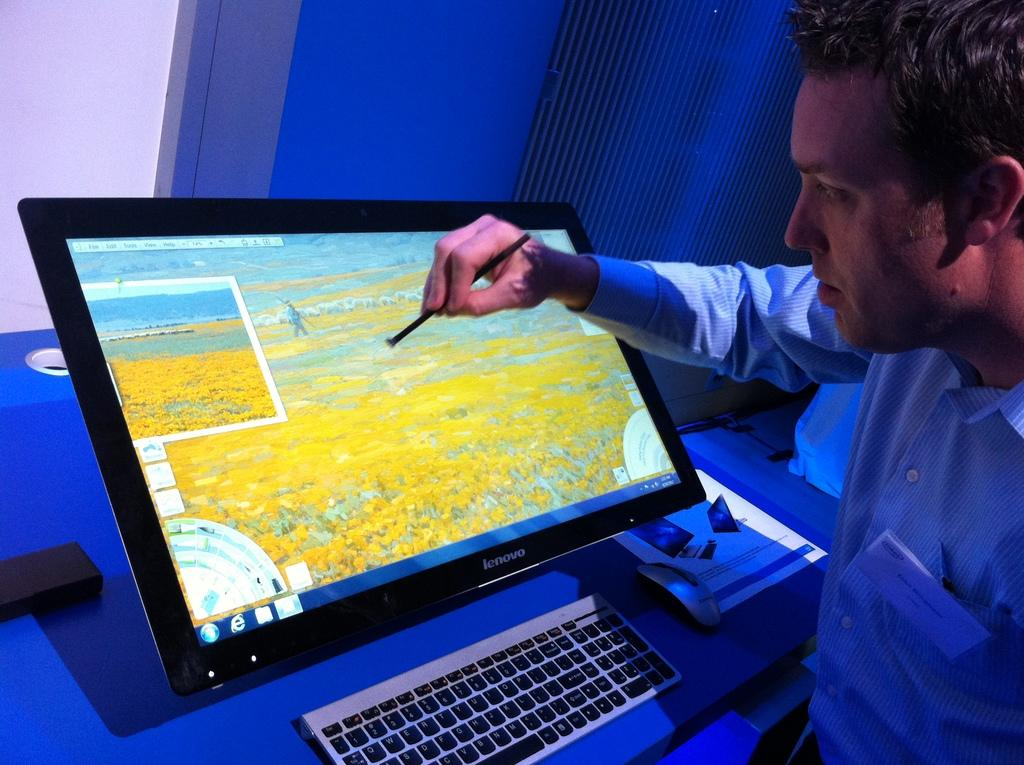<image>
Share a concise interpretation of the image provided. A man touching a computer screen with a stylus, the screen is Lenovo 